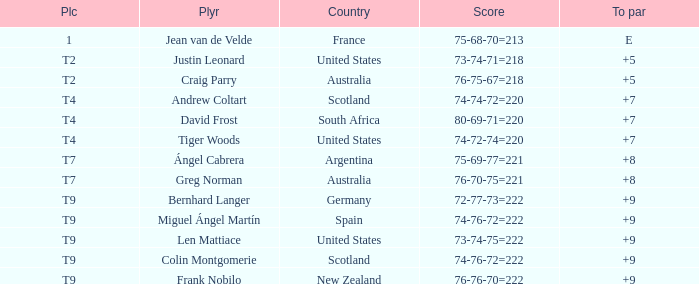Player Craig Parry of Australia is in what place number? T2. 